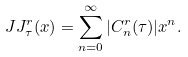Convert formula to latex. <formula><loc_0><loc_0><loc_500><loc_500>\ J J _ { \tau } ^ { r } ( x ) = \sum _ { n = 0 } ^ { \infty } | C _ { n } ^ { r } ( \tau ) | x ^ { n } .</formula> 